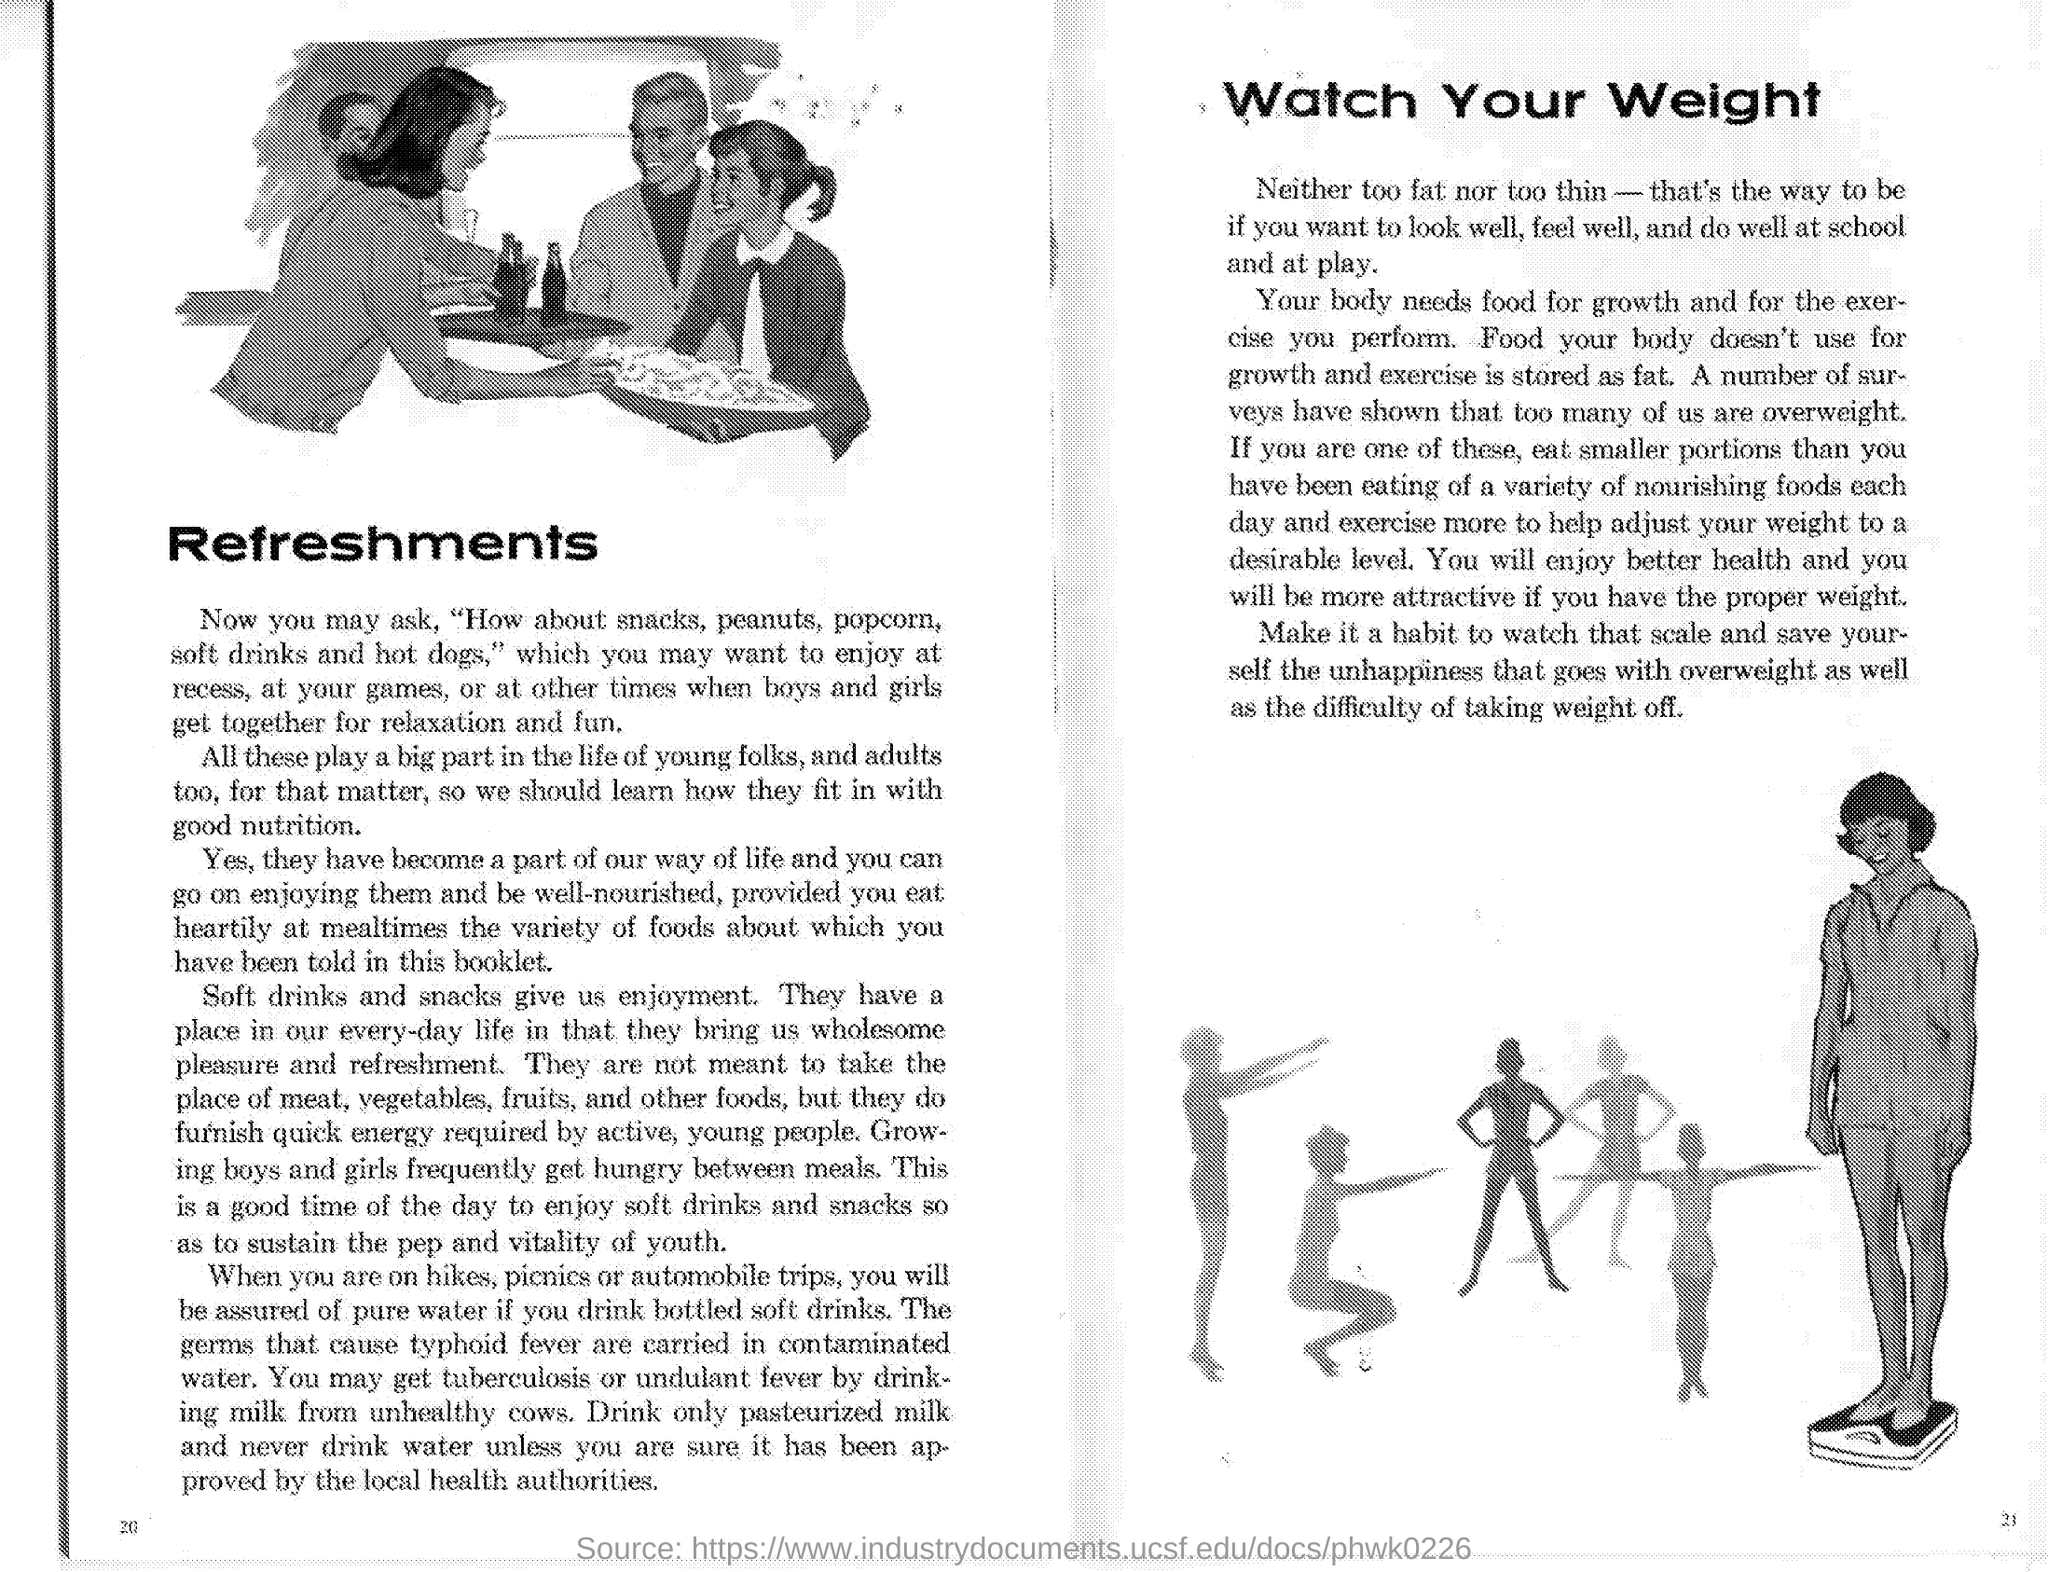Mention a couple of crucial points in this snapshot. Soft drinks and snacks are what give us enjoyment, as mentioned under the heading "Refreshments". Too many of us are overweight, as a number of surveys have shown. The first side heading is 'Refreshments.' The second heading on the side reads 'watch your weight,' According to the article, you will enjoy better health and become more attractive if you maintain proper weight. 